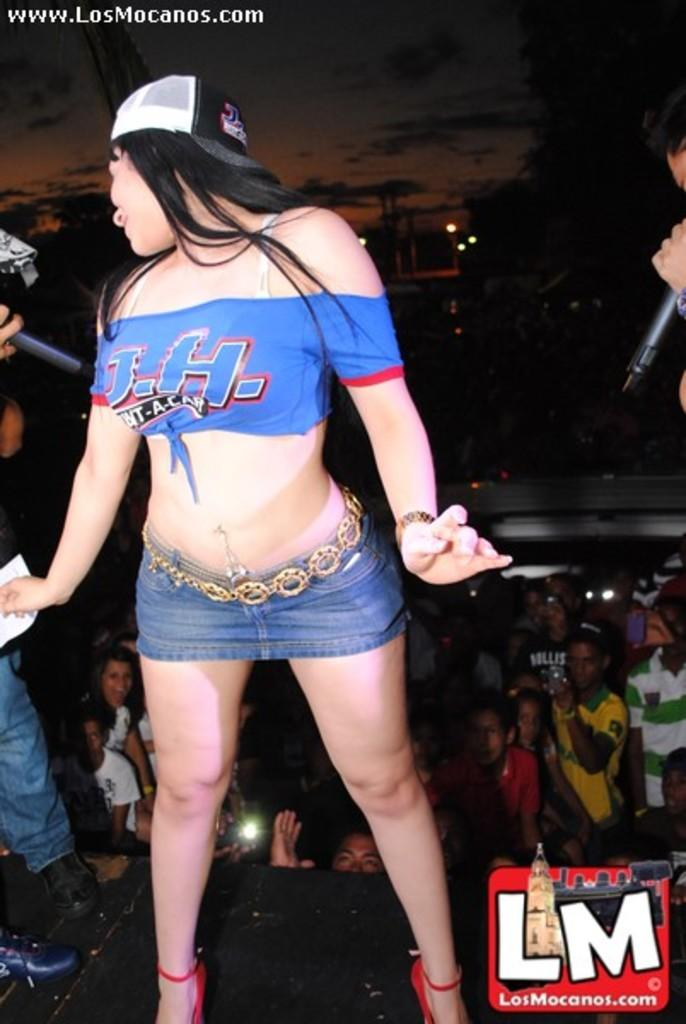Provide a one-sentence caption for the provided image. a girl in a small shirt and short skirt is an ad for the losmocanos.com. 